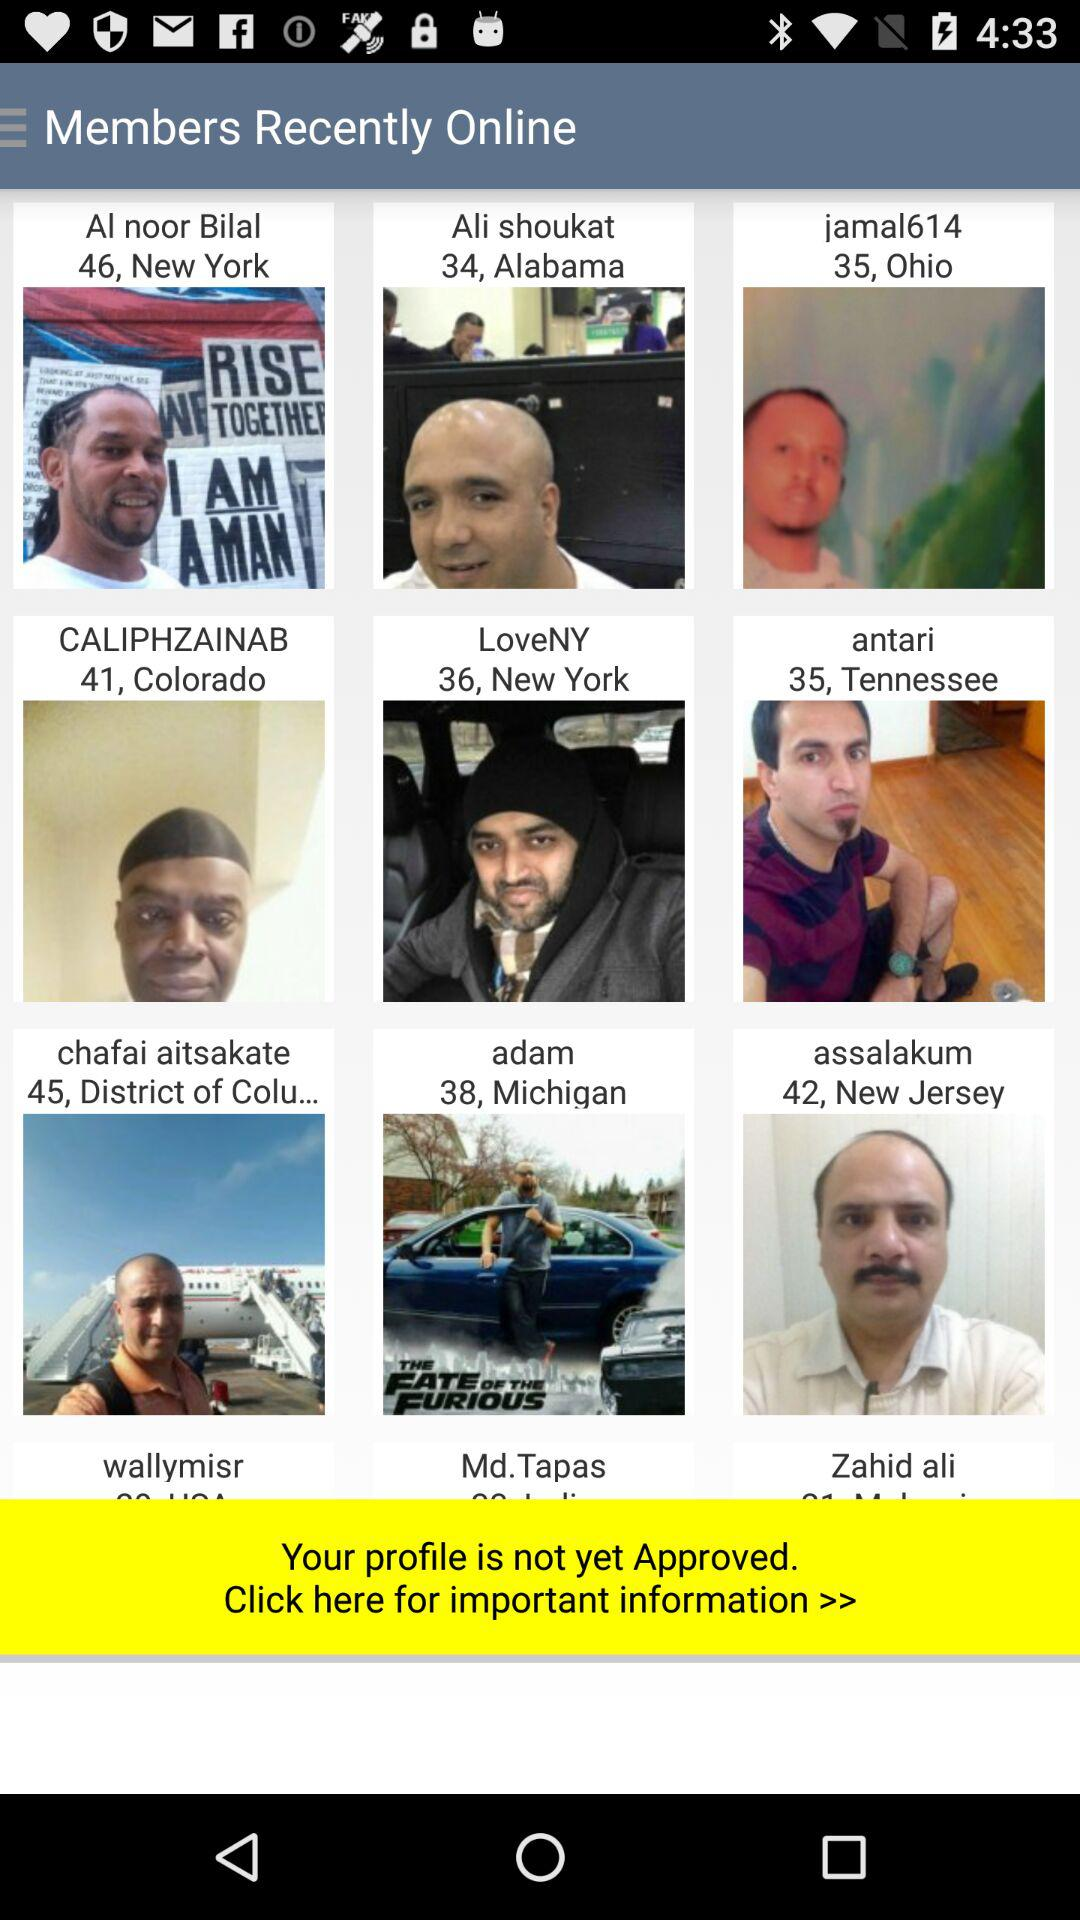Which person is 41 years old? The person is Caliphzainab. 